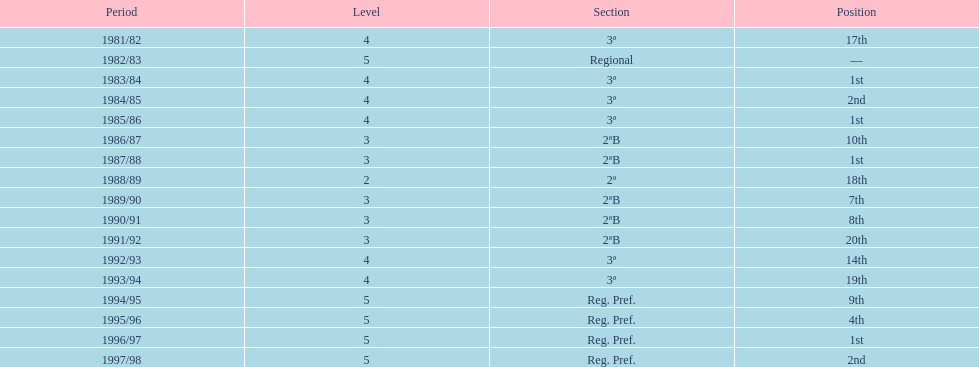What year has no place indicated? 1982/83. 